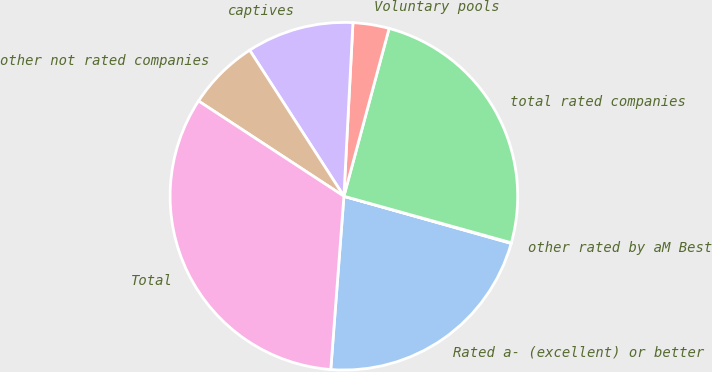Convert chart. <chart><loc_0><loc_0><loc_500><loc_500><pie_chart><fcel>Rated a- (excellent) or better<fcel>other rated by aM Best<fcel>total rated companies<fcel>Voluntary pools<fcel>captives<fcel>other not rated companies<fcel>Total<nl><fcel>21.83%<fcel>0.06%<fcel>25.13%<fcel>3.36%<fcel>9.95%<fcel>6.65%<fcel>33.03%<nl></chart> 